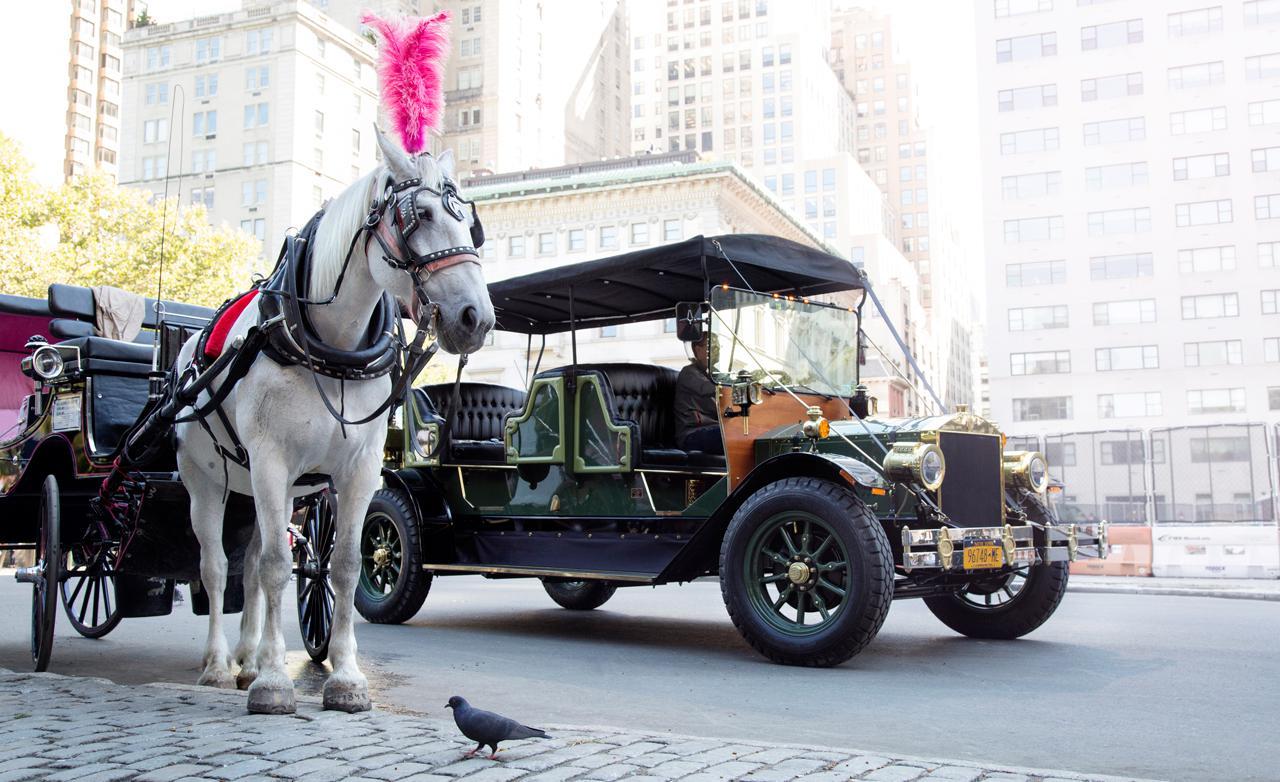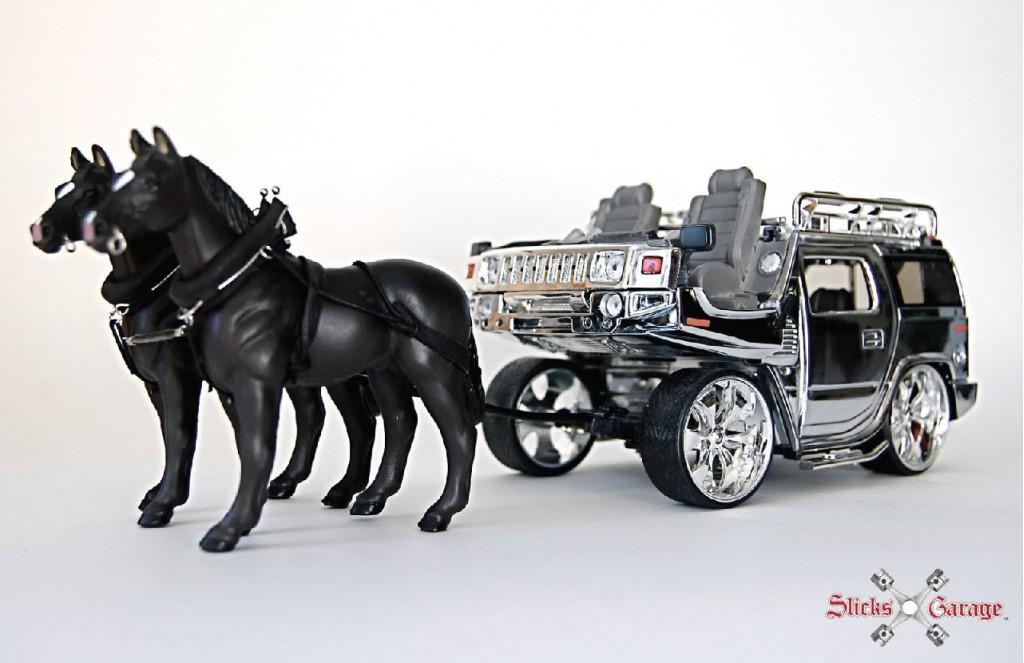The first image is the image on the left, the second image is the image on the right. For the images shown, is this caption "The left image has a horse carriage in an urban area." true? Answer yes or no. Yes. The first image is the image on the left, the second image is the image on the right. Examine the images to the left and right. Is the description "The horse-drawn cart on the right side is located in a rural setting." accurate? Answer yes or no. No. 